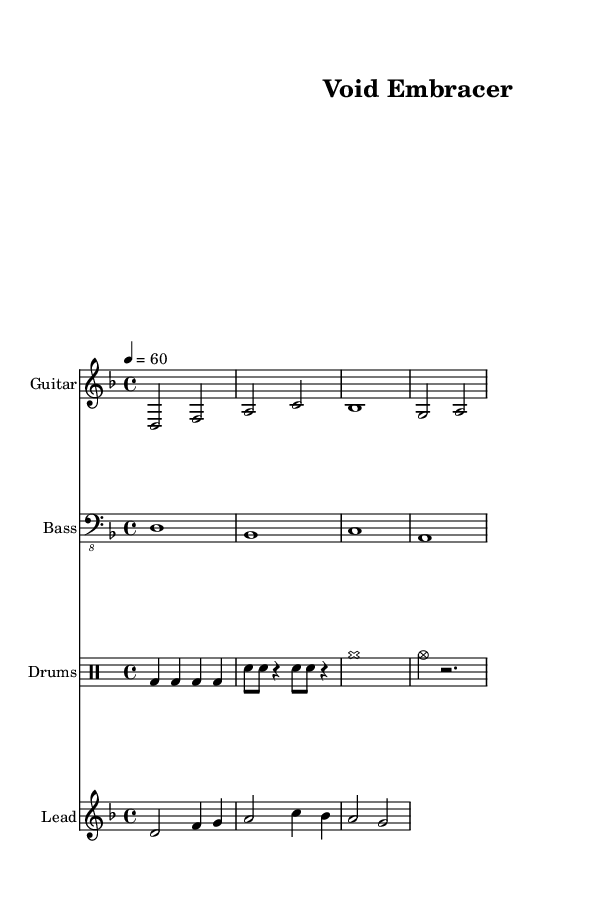What is the key signature of this music? The key signature is indicated by the number of sharps or flats at the beginning of the staff. In this case, there is one flat (B♭), which indicates that the key is D minor.
Answer: D minor What is the time signature of this music? The time signature is found at the beginning of the score, expressed as a fraction. Here, the time signature shows four beats in each measure (4) with a quarter note getting the beat (4), so it’s 4/4.
Answer: 4/4 What is the tempo marking for this piece? The tempo marking is represented by a number and note value, found above the staff. Here, it indicates a beat of 60 per minute, meaning the quarter note gets one beat.
Answer: 60 How many measures does the guitar riff contain? The guitar riff is depicted in the score with vertical lines separating the sections. Counting these lines indicates there are four measures in the guitar section.
Answer: 4 What type of drum is played at the beginning of the drum pattern? The drum notation starts with "bd", which stands for bass drum, as indicated in the drum pattern section of the score.
Answer: Bass drum What rhythmic pattern is used in the drum section? By examining the drum pattern closely, the rhythm consists of a consistent quarter note pattern followed by an alternating snare and rest pattern, making it a steady and hypnotic rhythm throughout.
Answer: Steady and hypnotic What is the overall mood suggested by the slow tempo and musical style? The overall mood can be deduced from the heavy, slow riffs and deep tones characteristic of doom metal, which typically evokes a sense of heaviness and introspection, promoting relaxation or stress relief.
Answer: Relaxation 